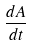Convert formula to latex. <formula><loc_0><loc_0><loc_500><loc_500>\frac { d A } { d t }</formula> 